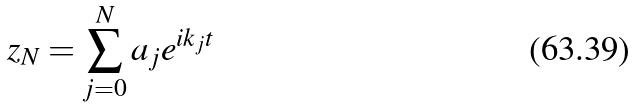Convert formula to latex. <formula><loc_0><loc_0><loc_500><loc_500>z _ { N } = \sum _ { j = 0 } ^ { N } a _ { j } e ^ { i k _ { j } t }</formula> 